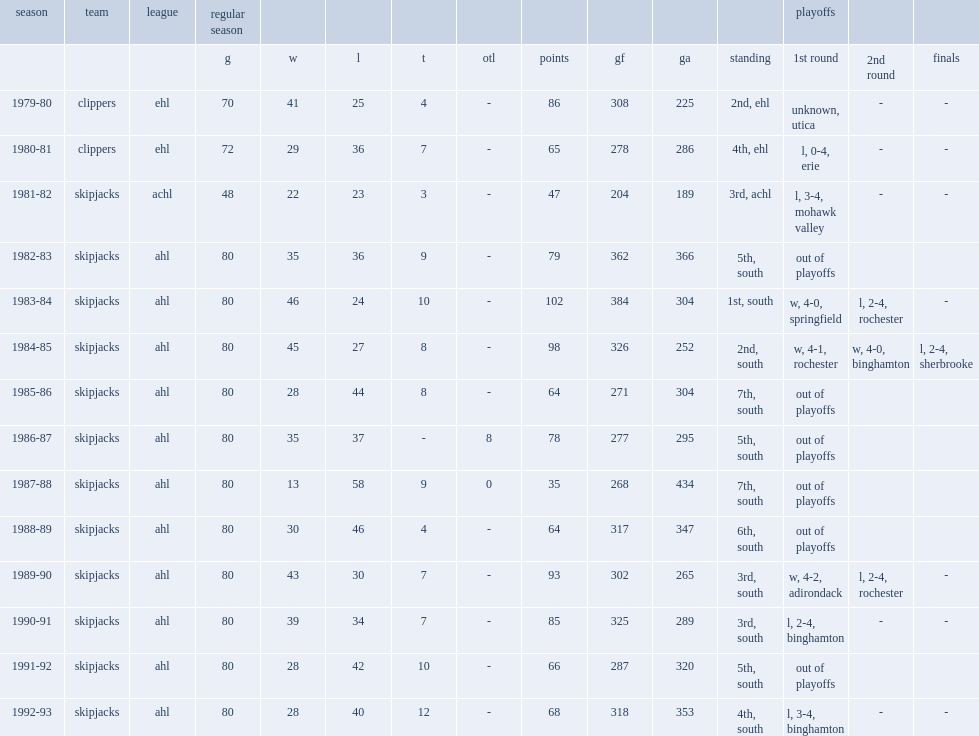Give me the full table as a dictionary. {'header': ['season', 'team', 'league', 'regular season', '', '', '', '', '', '', '', '', 'playoffs', '', ''], 'rows': [['', '', '', 'g', 'w', 'l', 't', 'otl', 'points', 'gf', 'ga', 'standing', '1st round', '2nd round', 'finals'], ['1979-80', 'clippers', 'ehl', '70', '41', '25', '4', '-', '86', '308', '225', '2nd, ehl', 'unknown, utica', '-', '-'], ['1980-81', 'clippers', 'ehl', '72', '29', '36', '7', '-', '65', '278', '286', '4th, ehl', 'l, 0-4, erie', '-', '-'], ['1981-82', 'skipjacks', 'achl', '48', '22', '23', '3', '-', '47', '204', '189', '3rd, achl', 'l, 3-4, mohawk valley', '-', '-'], ['1982-83', 'skipjacks', 'ahl', '80', '35', '36', '9', '-', '79', '362', '366', '5th, south', 'out of playoffs', '', ''], ['1983-84', 'skipjacks', 'ahl', '80', '46', '24', '10', '-', '102', '384', '304', '1st, south', 'w, 4-0, springfield', 'l, 2-4, rochester', '-'], ['1984-85', 'skipjacks', 'ahl', '80', '45', '27', '8', '-', '98', '326', '252', '2nd, south', 'w, 4-1, rochester', 'w, 4-0, binghamton', 'l, 2-4, sherbrooke'], ['1985-86', 'skipjacks', 'ahl', '80', '28', '44', '8', '-', '64', '271', '304', '7th, south', 'out of playoffs', '', ''], ['1986-87', 'skipjacks', 'ahl', '80', '35', '37', '-', '8', '78', '277', '295', '5th, south', 'out of playoffs', '', ''], ['1987-88', 'skipjacks', 'ahl', '80', '13', '58', '9', '0', '35', '268', '434', '7th, south', 'out of playoffs', '', ''], ['1988-89', 'skipjacks', 'ahl', '80', '30', '46', '4', '-', '64', '317', '347', '6th, south', 'out of playoffs', '', ''], ['1989-90', 'skipjacks', 'ahl', '80', '43', '30', '7', '-', '93', '302', '265', '3rd, south', 'w, 4-2, adirondack', 'l, 2-4, rochester', '-'], ['1990-91', 'skipjacks', 'ahl', '80', '39', '34', '7', '-', '85', '325', '289', '3rd, south', 'l, 2-4, binghamton', '-', '-'], ['1991-92', 'skipjacks', 'ahl', '80', '28', '42', '10', '-', '66', '287', '320', '5th, south', 'out of playoffs', '', ''], ['1992-93', 'skipjacks', 'ahl', '80', '28', '40', '12', '-', '68', '318', '353', '4th, south', 'l, 3-4, binghamton', '-', '-']]} What was the rank that the skipjacks finished in the 1981-82 achl season? 3rd, achl. 